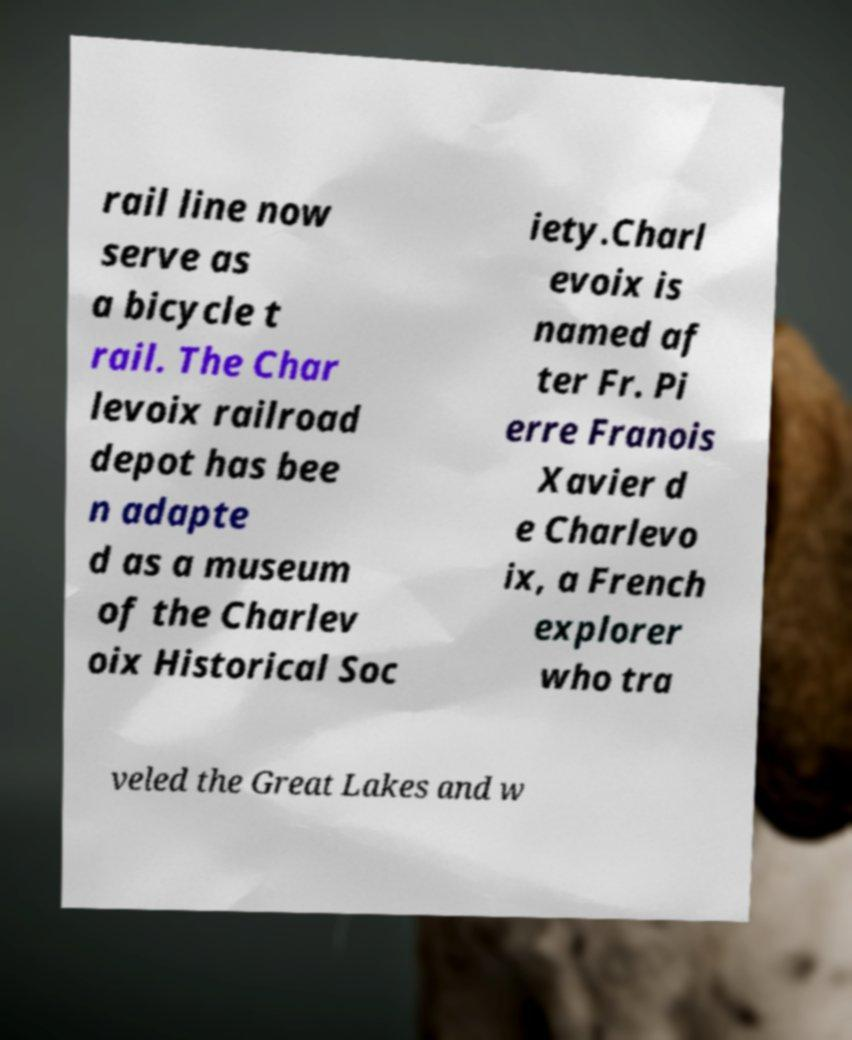Could you assist in decoding the text presented in this image and type it out clearly? rail line now serve as a bicycle t rail. The Char levoix railroad depot has bee n adapte d as a museum of the Charlev oix Historical Soc iety.Charl evoix is named af ter Fr. Pi erre Franois Xavier d e Charlevo ix, a French explorer who tra veled the Great Lakes and w 